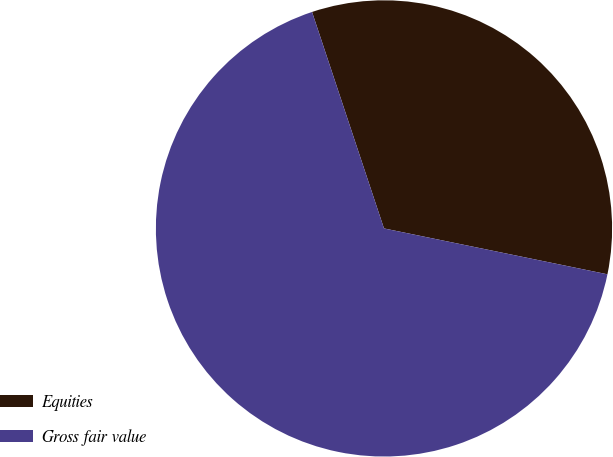Convert chart. <chart><loc_0><loc_0><loc_500><loc_500><pie_chart><fcel>Equities<fcel>Gross fair value<nl><fcel>33.33%<fcel>66.67%<nl></chart> 